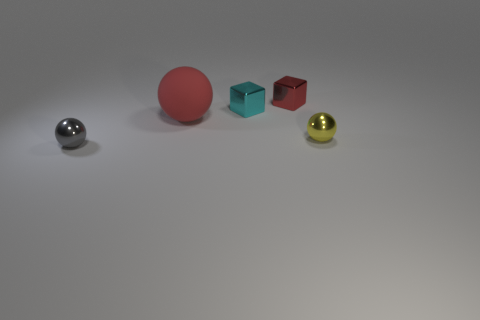Is there anything else that is the same size as the red rubber thing?
Keep it short and to the point. No. Is the material of the small red object the same as the sphere that is on the right side of the big rubber object?
Keep it short and to the point. Yes. What is the material of the other tiny gray thing that is the same shape as the rubber object?
Your response must be concise. Metal. Are there any other things that have the same material as the red sphere?
Give a very brief answer. No. Are there more metallic spheres on the right side of the small gray metallic object than cyan blocks behind the small red object?
Your answer should be very brief. Yes. What is the shape of the cyan object that is made of the same material as the yellow ball?
Provide a short and direct response. Cube. How many other objects are there of the same shape as the red matte thing?
Your answer should be very brief. 2. There is a gray thing to the left of the large red sphere; what is its shape?
Your answer should be compact. Sphere. What is the color of the rubber thing?
Offer a terse response. Red. How many other objects are the same size as the red matte thing?
Provide a succinct answer. 0. 